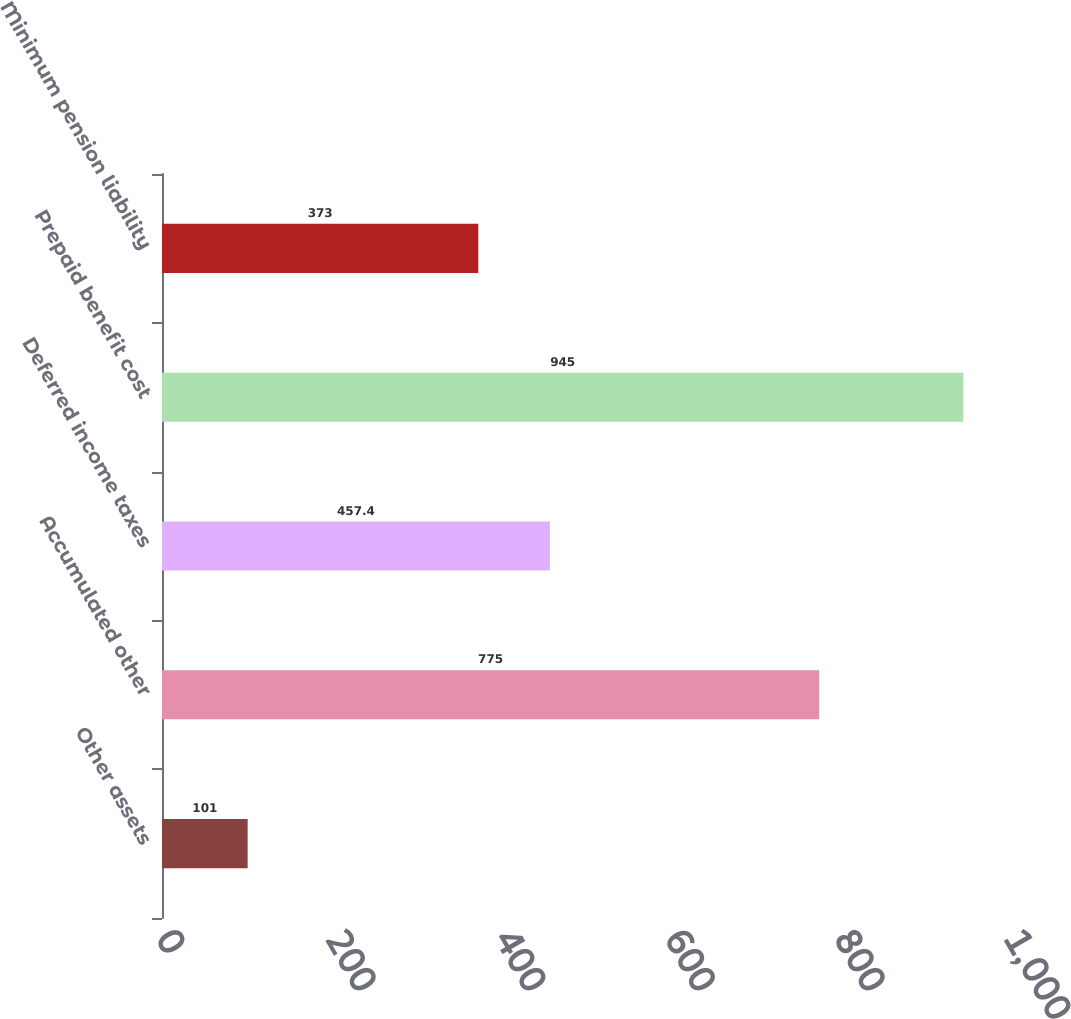Convert chart. <chart><loc_0><loc_0><loc_500><loc_500><bar_chart><fcel>Other assets<fcel>Accumulated other<fcel>Deferred income taxes<fcel>Prepaid benefit cost<fcel>Minimum pension liability<nl><fcel>101<fcel>775<fcel>457.4<fcel>945<fcel>373<nl></chart> 